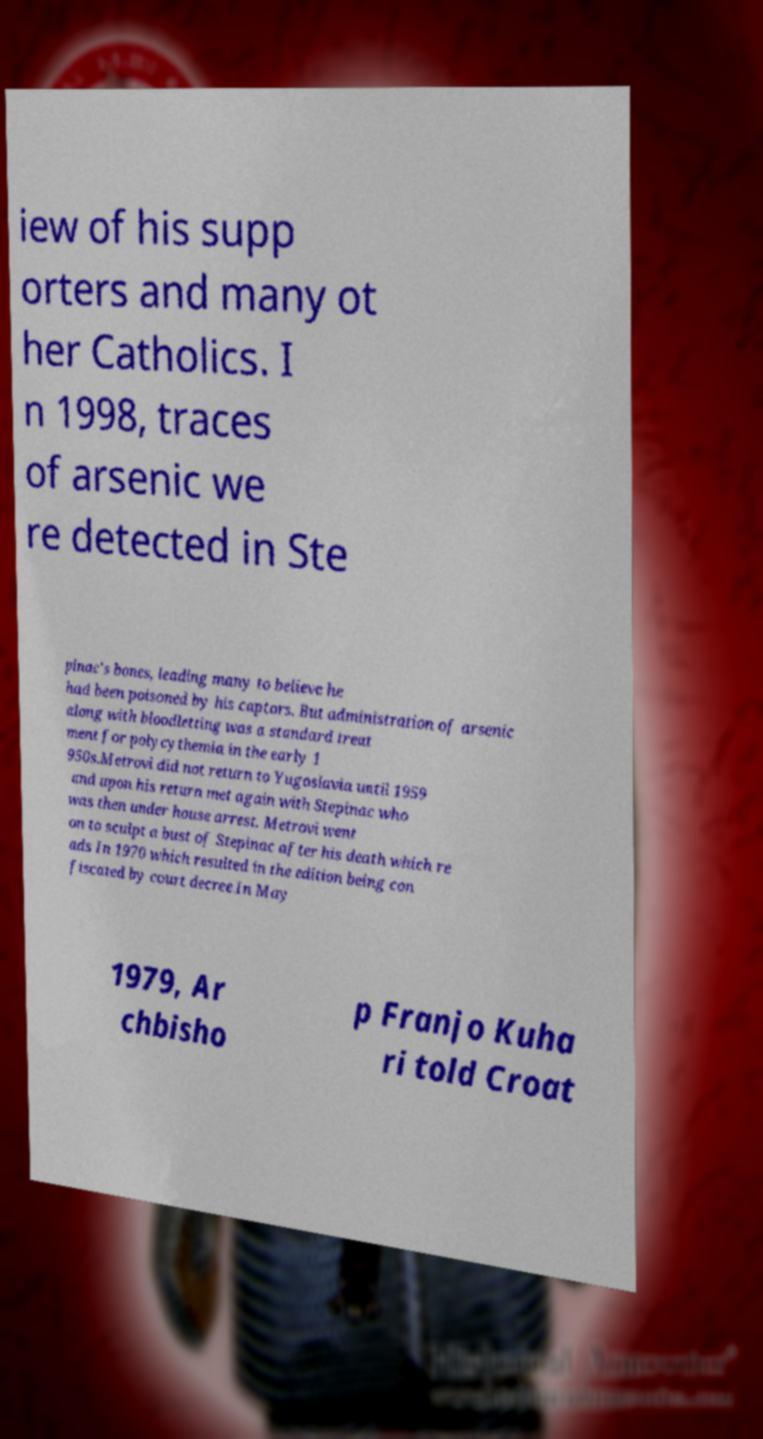I need the written content from this picture converted into text. Can you do that? iew of his supp orters and many ot her Catholics. I n 1998, traces of arsenic we re detected in Ste pinac's bones, leading many to believe he had been poisoned by his captors. But administration of arsenic along with bloodletting was a standard treat ment for polycythemia in the early 1 950s.Metrovi did not return to Yugoslavia until 1959 and upon his return met again with Stepinac who was then under house arrest. Metrovi went on to sculpt a bust of Stepinac after his death which re ads In 1970 which resulted in the edition being con fiscated by court decree.In May 1979, Ar chbisho p Franjo Kuha ri told Croat 